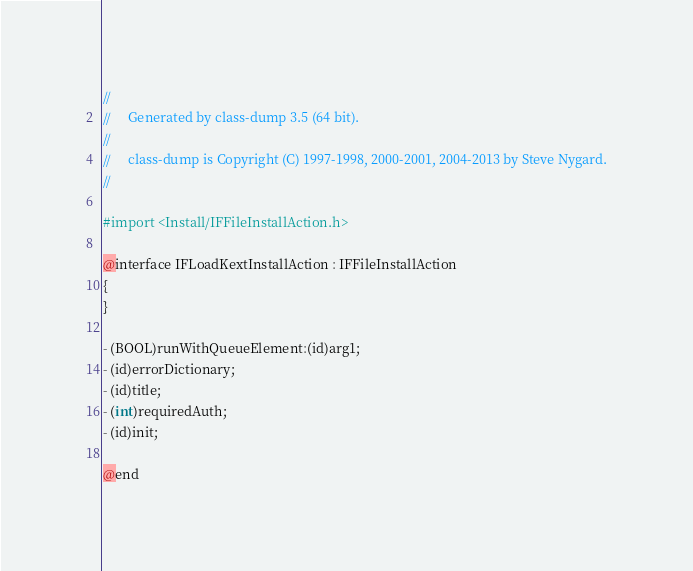Convert code to text. <code><loc_0><loc_0><loc_500><loc_500><_C_>//
//     Generated by class-dump 3.5 (64 bit).
//
//     class-dump is Copyright (C) 1997-1998, 2000-2001, 2004-2013 by Steve Nygard.
//

#import <Install/IFFileInstallAction.h>

@interface IFLoadKextInstallAction : IFFileInstallAction
{
}

- (BOOL)runWithQueueElement:(id)arg1;
- (id)errorDictionary;
- (id)title;
- (int)requiredAuth;
- (id)init;

@end

</code> 